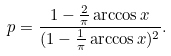<formula> <loc_0><loc_0><loc_500><loc_500>p = \frac { 1 - \frac { 2 } { \pi } \arccos x } { ( 1 - \frac { 1 } { \pi } \arccos x ) ^ { 2 } } .</formula> 